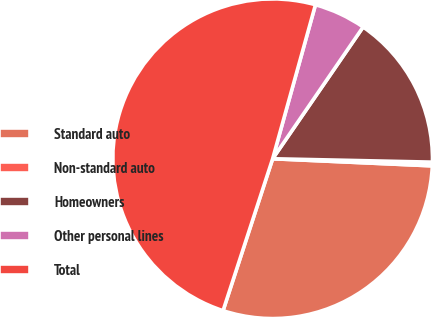Convert chart. <chart><loc_0><loc_0><loc_500><loc_500><pie_chart><fcel>Standard auto<fcel>Non-standard auto<fcel>Homeowners<fcel>Other personal lines<fcel>Total<nl><fcel>29.31%<fcel>0.37%<fcel>15.76%<fcel>5.26%<fcel>49.29%<nl></chart> 